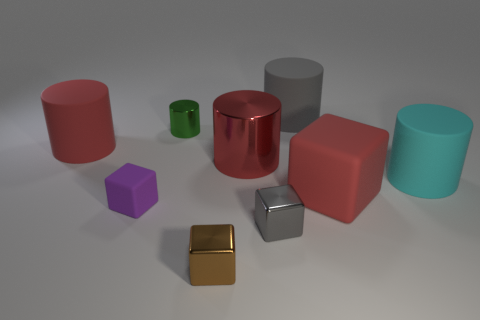What is the material of the red object behind the red metal thing?
Your answer should be very brief. Rubber. There is a large red matte thing to the right of the tiny rubber object; does it have the same shape as the large gray rubber thing right of the tiny metallic cylinder?
Your answer should be very brief. No. Are there the same number of large cubes that are to the left of the small brown metallic block and yellow rubber balls?
Provide a short and direct response. Yes. How many other cylinders have the same material as the tiny green cylinder?
Give a very brief answer. 1. What is the color of the small object that is the same material as the large cyan cylinder?
Offer a very short reply. Purple. Do the cyan matte object and the red thing in front of the cyan object have the same size?
Provide a succinct answer. Yes. The purple thing has what shape?
Your answer should be compact. Cube. How many metallic cubes are the same color as the large metallic cylinder?
Give a very brief answer. 0. What color is the other rubber object that is the same shape as the tiny purple rubber object?
Offer a very short reply. Red. There is a large red cube that is in front of the tiny green metallic cylinder; how many red shiny cylinders are to the left of it?
Give a very brief answer. 1. 